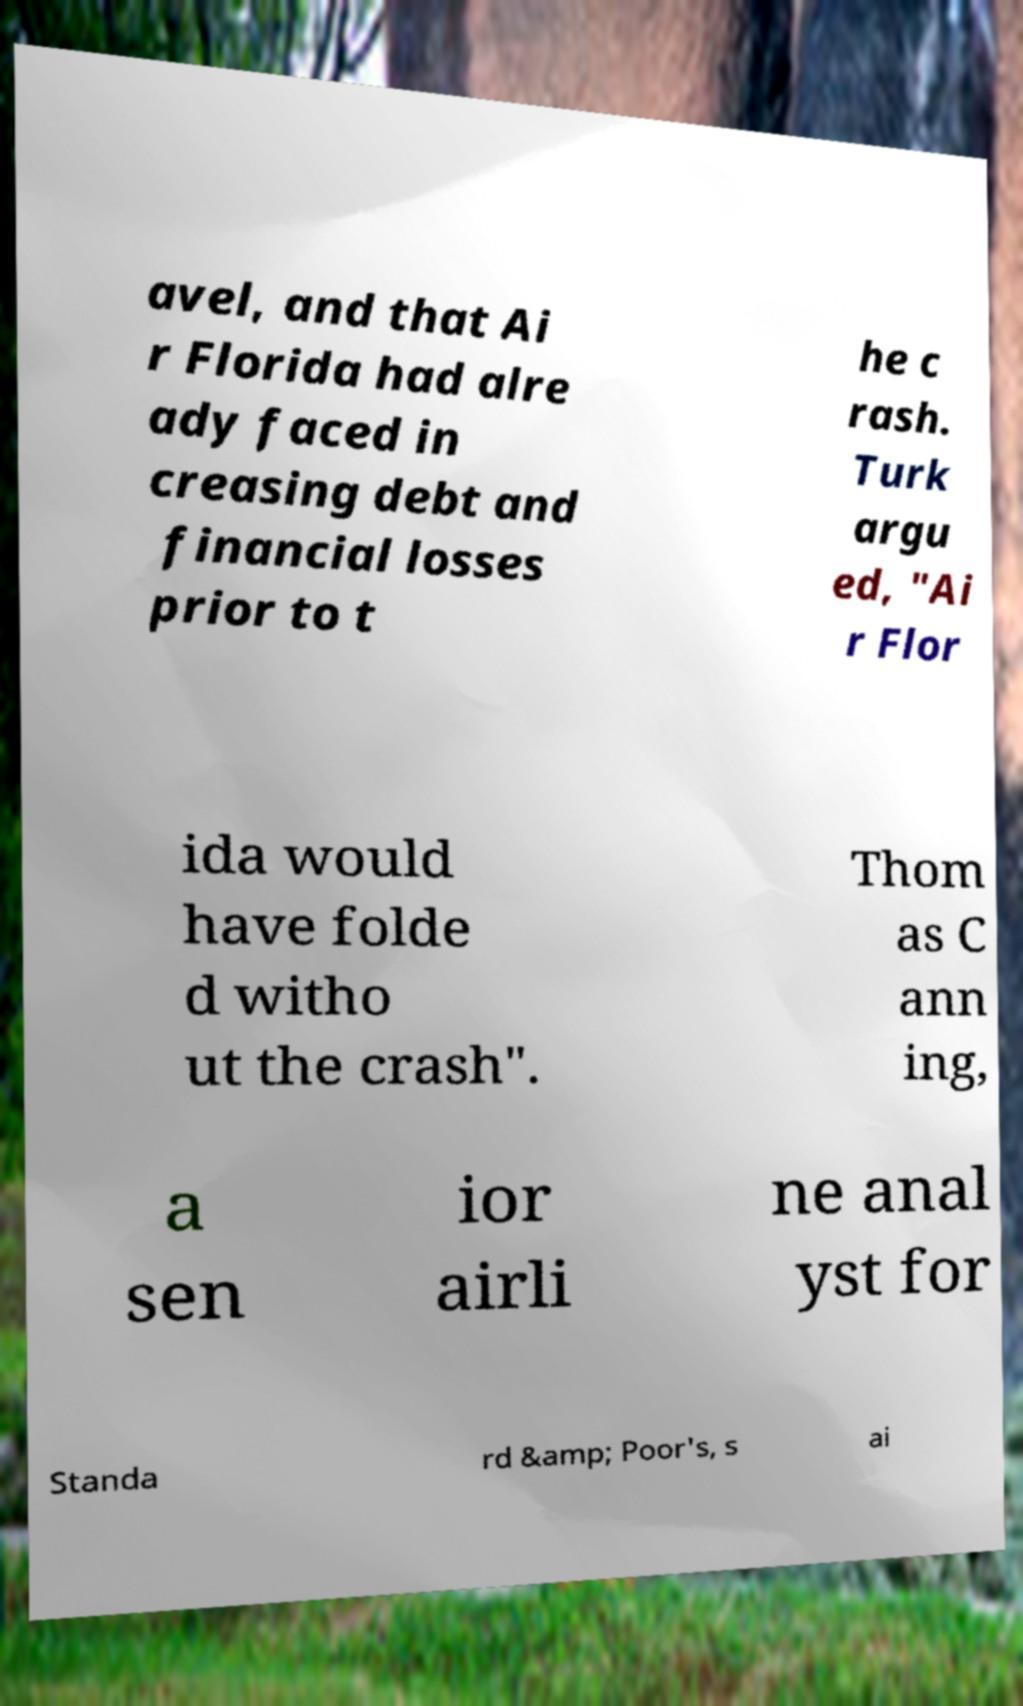What messages or text are displayed in this image? I need them in a readable, typed format. avel, and that Ai r Florida had alre ady faced in creasing debt and financial losses prior to t he c rash. Turk argu ed, "Ai r Flor ida would have folde d witho ut the crash". Thom as C ann ing, a sen ior airli ne anal yst for Standa rd &amp; Poor's, s ai 